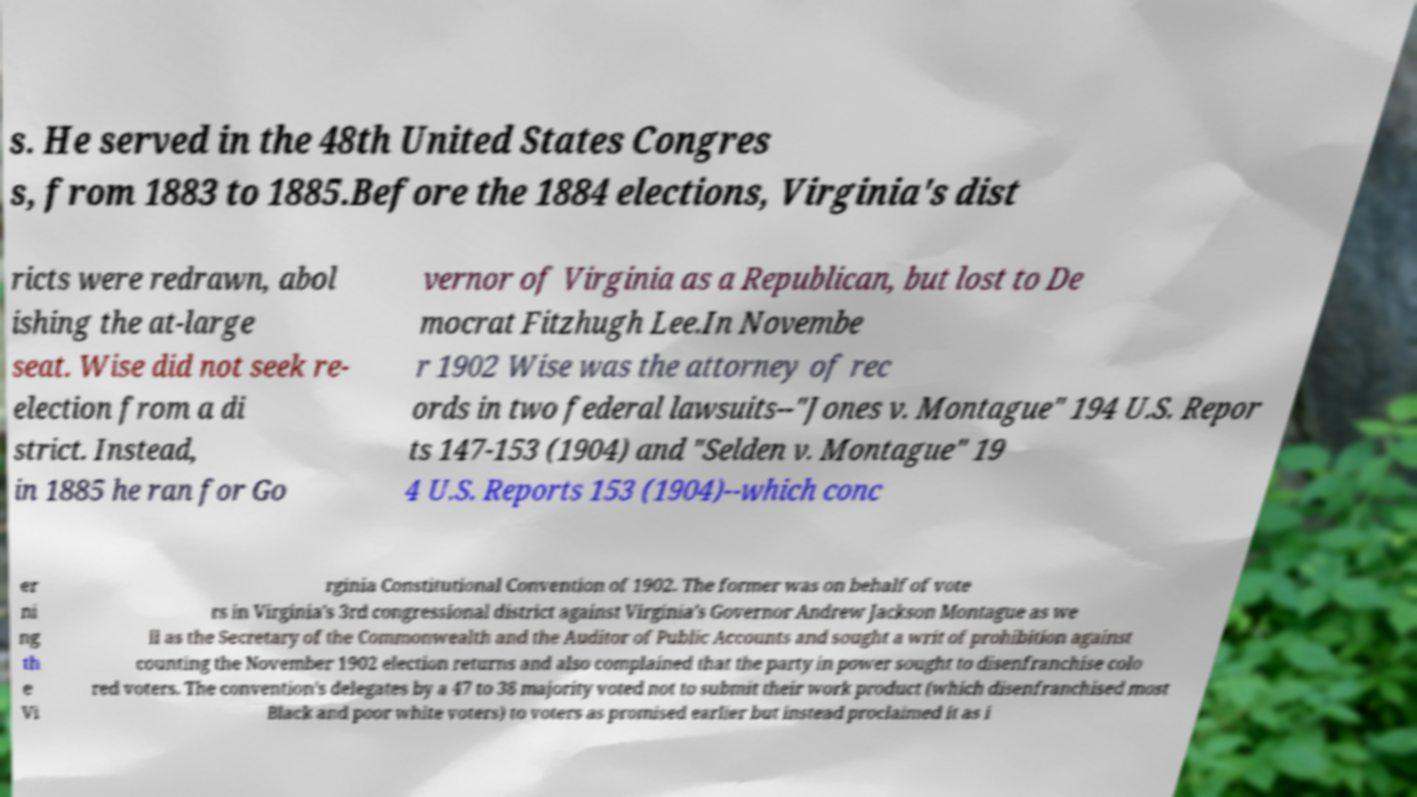For documentation purposes, I need the text within this image transcribed. Could you provide that? s. He served in the 48th United States Congres s, from 1883 to 1885.Before the 1884 elections, Virginia's dist ricts were redrawn, abol ishing the at-large seat. Wise did not seek re- election from a di strict. Instead, in 1885 he ran for Go vernor of Virginia as a Republican, but lost to De mocrat Fitzhugh Lee.In Novembe r 1902 Wise was the attorney of rec ords in two federal lawsuits--"Jones v. Montague" 194 U.S. Repor ts 147-153 (1904) and "Selden v. Montague" 19 4 U.S. Reports 153 (1904)--which conc er ni ng th e Vi rginia Constitutional Convention of 1902. The former was on behalf of vote rs in Virginia's 3rd congressional district against Virginia's Governor Andrew Jackson Montague as we ll as the Secretary of the Commonwealth and the Auditor of Public Accounts and sought a writ of prohibition against counting the November 1902 election returns and also complained that the party in power sought to disenfranchise colo red voters. The convention's delegates by a 47 to 38 majority voted not to submit their work product (which disenfranchised most Black and poor white voters) to voters as promised earlier but instead proclaimed it as i 